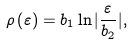<formula> <loc_0><loc_0><loc_500><loc_500>\rho \left ( \varepsilon \right ) = b _ { 1 } \ln | \frac { \varepsilon } { b _ { 2 } } | ,</formula> 